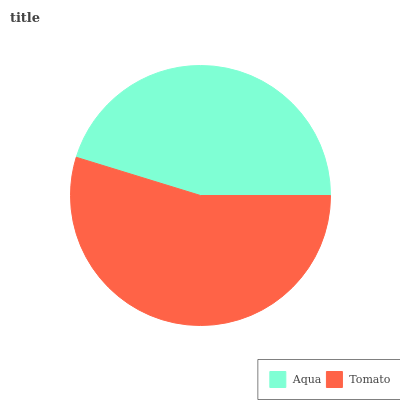Is Aqua the minimum?
Answer yes or no. Yes. Is Tomato the maximum?
Answer yes or no. Yes. Is Tomato the minimum?
Answer yes or no. No. Is Tomato greater than Aqua?
Answer yes or no. Yes. Is Aqua less than Tomato?
Answer yes or no. Yes. Is Aqua greater than Tomato?
Answer yes or no. No. Is Tomato less than Aqua?
Answer yes or no. No. Is Tomato the high median?
Answer yes or no. Yes. Is Aqua the low median?
Answer yes or no. Yes. Is Aqua the high median?
Answer yes or no. No. Is Tomato the low median?
Answer yes or no. No. 